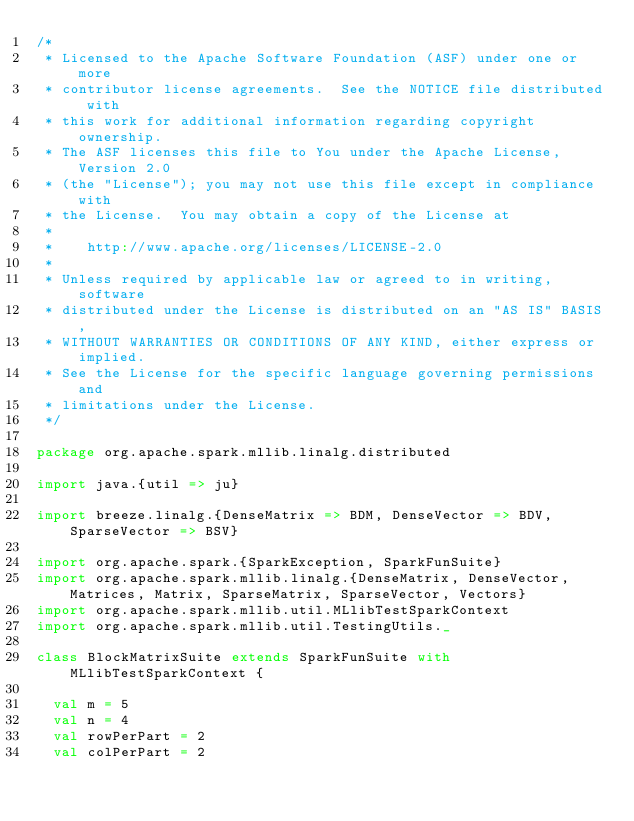Convert code to text. <code><loc_0><loc_0><loc_500><loc_500><_Scala_>/*
 * Licensed to the Apache Software Foundation (ASF) under one or more
 * contributor license agreements.  See the NOTICE file distributed with
 * this work for additional information regarding copyright ownership.
 * The ASF licenses this file to You under the Apache License, Version 2.0
 * (the "License"); you may not use this file except in compliance with
 * the License.  You may obtain a copy of the License at
 *
 *    http://www.apache.org/licenses/LICENSE-2.0
 *
 * Unless required by applicable law or agreed to in writing, software
 * distributed under the License is distributed on an "AS IS" BASIS,
 * WITHOUT WARRANTIES OR CONDITIONS OF ANY KIND, either express or implied.
 * See the License for the specific language governing permissions and
 * limitations under the License.
 */

package org.apache.spark.mllib.linalg.distributed

import java.{util => ju}

import breeze.linalg.{DenseMatrix => BDM, DenseVector => BDV, SparseVector => BSV}

import org.apache.spark.{SparkException, SparkFunSuite}
import org.apache.spark.mllib.linalg.{DenseMatrix, DenseVector, Matrices, Matrix, SparseMatrix, SparseVector, Vectors}
import org.apache.spark.mllib.util.MLlibTestSparkContext
import org.apache.spark.mllib.util.TestingUtils._

class BlockMatrixSuite extends SparkFunSuite with MLlibTestSparkContext {

  val m = 5
  val n = 4
  val rowPerPart = 2
  val colPerPart = 2</code> 